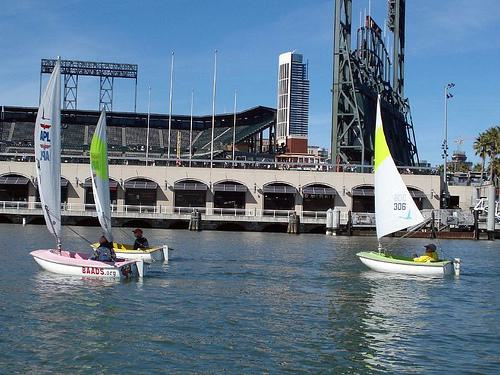What's the significance of the numbers on the sails? The numbers on the sails are likely identifiers for the sailboats, which are used for organizational and competition purposes. This allows judges, spectators, and participants to distinguish between the different boats during sailing events or races. 